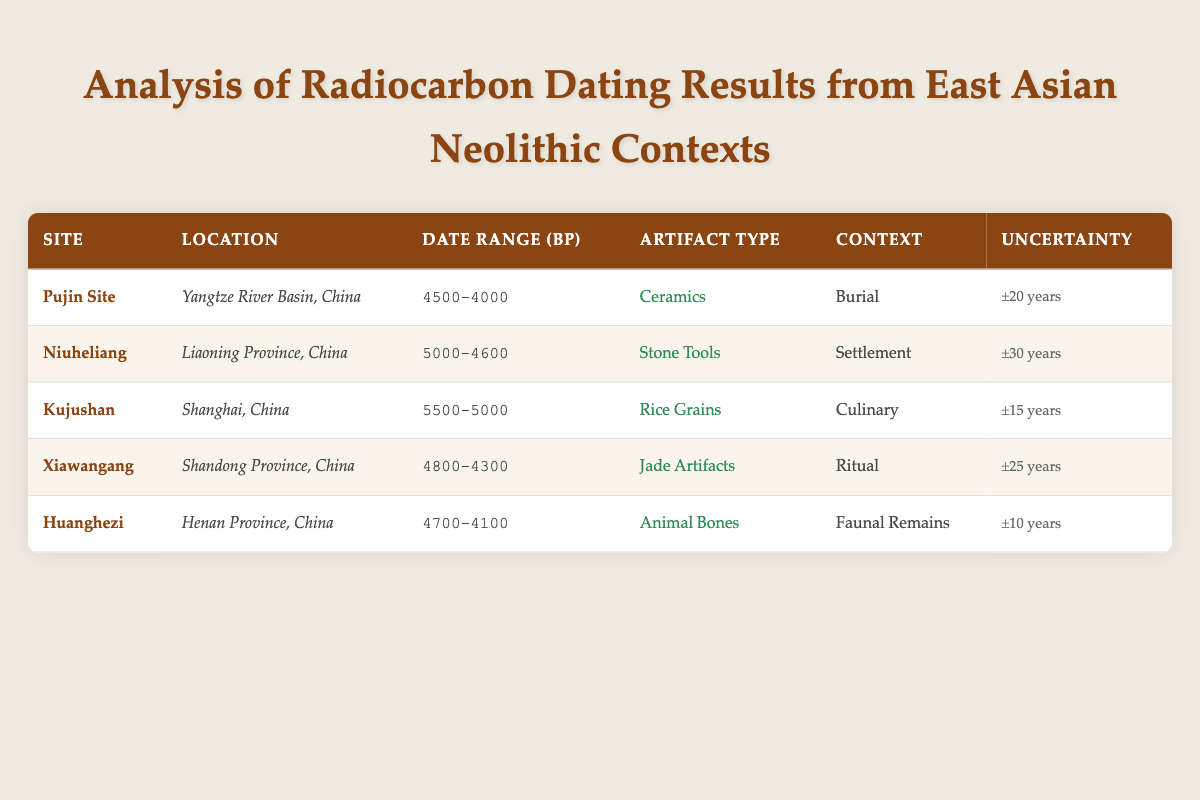What is the artifact type found at the Pujin Site? According to the table, the artifact type for the Pujin Site is Ceramics as listed in the corresponding row under the "Artifact Type" column.
Answer: Ceramics Which site has the longest date range? The site Kujushan has the longest date range of 5500-5000 BP as seen in the “Date Range (BP)” column. Comparing ranges, Kujushan's span covers 500 years, while others span 400 years or less.
Answer: Kujushan Is there a site where animal bones were found? Yes, Huanghezi is the only site listed where animal bones are identified, as mentioned under the "Artifact Type" column.
Answer: Yes What is the uncertainty of the date range for Niuheliang? The uncertainty for Niuheliang, found in the table under the "Uncertainty" column, is ±30 years.
Answer: ±30 years Which site has both a burial context and a date range higher than 4000 BP? The Pujin Site has a burial context and a date range of 4500-4000 BP, qualifying it for both conditions as seen in the “Context” and “Date Range (BP)” columns.
Answer: Pujin Site Calculate the average uncertainty of the date ranges listed. To calculate the average uncertainty, first convert the uncertainties into numerical values (20, 30, 15, 25, 10). The sum is (20 + 30 + 15 + 25 + 10) = 110. With 5 data points, the average is 110/5 = 22.
Answer: 22 List the sites that have a date range starting later than 4700 BP. The sites with date ranges starting later than 4700 BP are Kujushan (5500-5000) and Niuheliang (5000-4600) as both begin above 4700 BP according to the "Date Range (BP)" column.
Answer: Kujushan, Niuheliang What context is associated with the Jade Artifacts found at Xiawangang? The context associated with Jade Artifacts found at Xiawangang is Ritual, as indicated in the table under the "Context" column.
Answer: Ritual How many sites have artifacts related to culinary contexts? According to the table, only one site—Kujushan—features artifacts related to culinary contexts, as shown in the “Context” column.
Answer: 1 